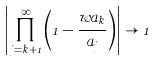Convert formula to latex. <formula><loc_0><loc_0><loc_500><loc_500>\left | \prod _ { j = k + 1 } ^ { \infty } \left ( 1 - \frac { w a _ { k } } { a _ { j } } \right ) \right | \to 1</formula> 